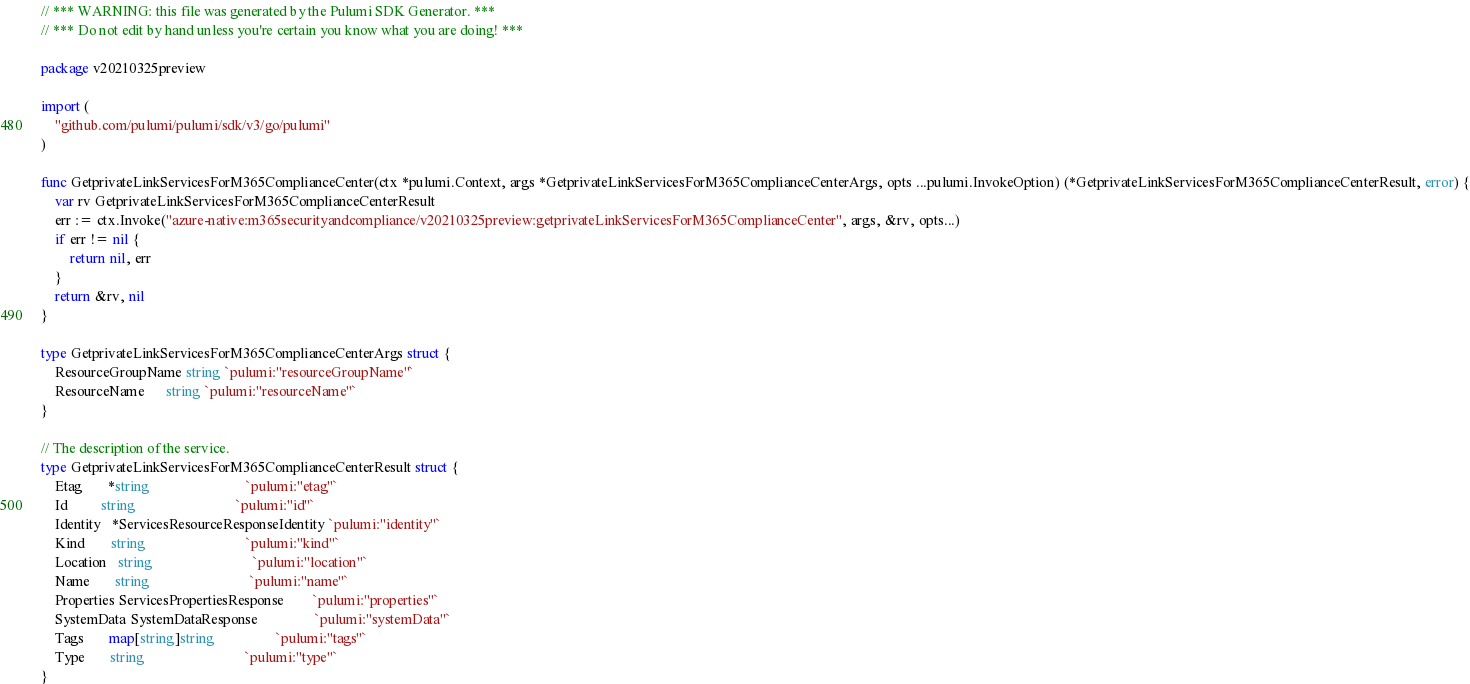Convert code to text. <code><loc_0><loc_0><loc_500><loc_500><_Go_>// *** WARNING: this file was generated by the Pulumi SDK Generator. ***
// *** Do not edit by hand unless you're certain you know what you are doing! ***

package v20210325preview

import (
	"github.com/pulumi/pulumi/sdk/v3/go/pulumi"
)

func GetprivateLinkServicesForM365ComplianceCenter(ctx *pulumi.Context, args *GetprivateLinkServicesForM365ComplianceCenterArgs, opts ...pulumi.InvokeOption) (*GetprivateLinkServicesForM365ComplianceCenterResult, error) {
	var rv GetprivateLinkServicesForM365ComplianceCenterResult
	err := ctx.Invoke("azure-native:m365securityandcompliance/v20210325preview:getprivateLinkServicesForM365ComplianceCenter", args, &rv, opts...)
	if err != nil {
		return nil, err
	}
	return &rv, nil
}

type GetprivateLinkServicesForM365ComplianceCenterArgs struct {
	ResourceGroupName string `pulumi:"resourceGroupName"`
	ResourceName      string `pulumi:"resourceName"`
}

// The description of the service.
type GetprivateLinkServicesForM365ComplianceCenterResult struct {
	Etag       *string                           `pulumi:"etag"`
	Id         string                            `pulumi:"id"`
	Identity   *ServicesResourceResponseIdentity `pulumi:"identity"`
	Kind       string                            `pulumi:"kind"`
	Location   string                            `pulumi:"location"`
	Name       string                            `pulumi:"name"`
	Properties ServicesPropertiesResponse        `pulumi:"properties"`
	SystemData SystemDataResponse                `pulumi:"systemData"`
	Tags       map[string]string                 `pulumi:"tags"`
	Type       string                            `pulumi:"type"`
}
</code> 